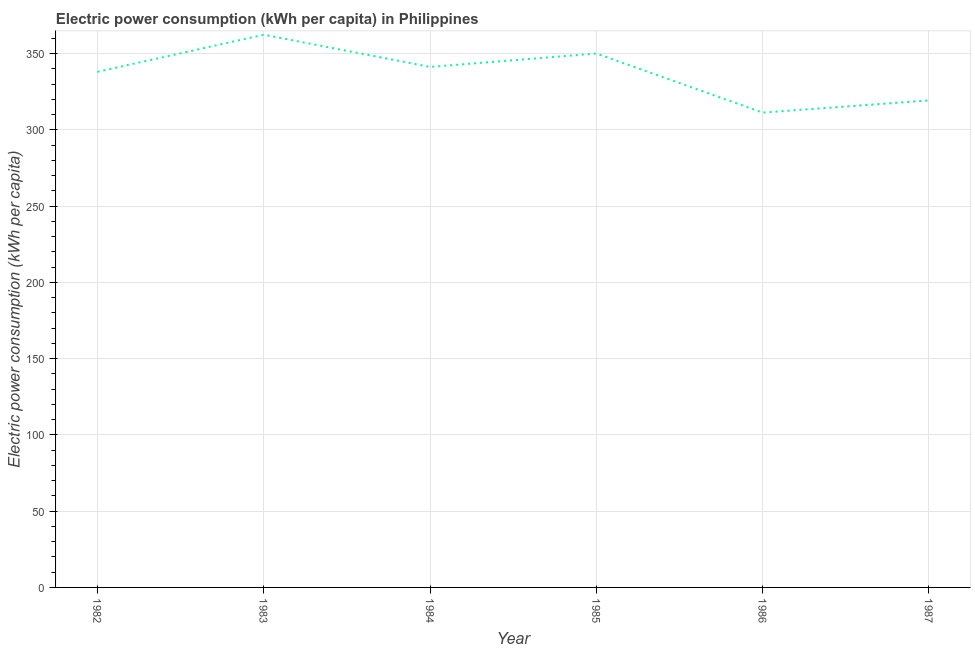What is the electric power consumption in 1984?
Provide a succinct answer. 341.32. Across all years, what is the maximum electric power consumption?
Offer a very short reply. 362.45. Across all years, what is the minimum electric power consumption?
Make the answer very short. 311.38. In which year was the electric power consumption maximum?
Provide a short and direct response. 1983. What is the sum of the electric power consumption?
Make the answer very short. 2022.78. What is the difference between the electric power consumption in 1982 and 1986?
Your answer should be very brief. 26.76. What is the average electric power consumption per year?
Offer a very short reply. 337.13. What is the median electric power consumption?
Make the answer very short. 339.73. In how many years, is the electric power consumption greater than 320 kWh per capita?
Ensure brevity in your answer.  4. What is the ratio of the electric power consumption in 1985 to that in 1987?
Offer a terse response. 1.1. Is the difference between the electric power consumption in 1985 and 1987 greater than the difference between any two years?
Your response must be concise. No. What is the difference between the highest and the second highest electric power consumption?
Make the answer very short. 12.33. Is the sum of the electric power consumption in 1983 and 1986 greater than the maximum electric power consumption across all years?
Make the answer very short. Yes. What is the difference between the highest and the lowest electric power consumption?
Keep it short and to the point. 51.08. In how many years, is the electric power consumption greater than the average electric power consumption taken over all years?
Give a very brief answer. 4. Does the electric power consumption monotonically increase over the years?
Your answer should be compact. No. How many lines are there?
Provide a succinct answer. 1. What is the difference between two consecutive major ticks on the Y-axis?
Make the answer very short. 50. Does the graph contain any zero values?
Offer a terse response. No. Does the graph contain grids?
Your response must be concise. Yes. What is the title of the graph?
Provide a short and direct response. Electric power consumption (kWh per capita) in Philippines. What is the label or title of the Y-axis?
Your response must be concise. Electric power consumption (kWh per capita). What is the Electric power consumption (kWh per capita) of 1982?
Ensure brevity in your answer.  338.14. What is the Electric power consumption (kWh per capita) of 1983?
Your response must be concise. 362.45. What is the Electric power consumption (kWh per capita) in 1984?
Give a very brief answer. 341.32. What is the Electric power consumption (kWh per capita) in 1985?
Ensure brevity in your answer.  350.12. What is the Electric power consumption (kWh per capita) of 1986?
Provide a short and direct response. 311.38. What is the Electric power consumption (kWh per capita) of 1987?
Ensure brevity in your answer.  319.37. What is the difference between the Electric power consumption (kWh per capita) in 1982 and 1983?
Your answer should be compact. -24.32. What is the difference between the Electric power consumption (kWh per capita) in 1982 and 1984?
Keep it short and to the point. -3.18. What is the difference between the Electric power consumption (kWh per capita) in 1982 and 1985?
Make the answer very short. -11.99. What is the difference between the Electric power consumption (kWh per capita) in 1982 and 1986?
Provide a succinct answer. 26.76. What is the difference between the Electric power consumption (kWh per capita) in 1982 and 1987?
Provide a short and direct response. 18.77. What is the difference between the Electric power consumption (kWh per capita) in 1983 and 1984?
Provide a succinct answer. 21.13. What is the difference between the Electric power consumption (kWh per capita) in 1983 and 1985?
Provide a succinct answer. 12.33. What is the difference between the Electric power consumption (kWh per capita) in 1983 and 1986?
Give a very brief answer. 51.08. What is the difference between the Electric power consumption (kWh per capita) in 1983 and 1987?
Offer a terse response. 43.08. What is the difference between the Electric power consumption (kWh per capita) in 1984 and 1985?
Your response must be concise. -8.8. What is the difference between the Electric power consumption (kWh per capita) in 1984 and 1986?
Make the answer very short. 29.95. What is the difference between the Electric power consumption (kWh per capita) in 1984 and 1987?
Give a very brief answer. 21.95. What is the difference between the Electric power consumption (kWh per capita) in 1985 and 1986?
Give a very brief answer. 38.75. What is the difference between the Electric power consumption (kWh per capita) in 1985 and 1987?
Offer a very short reply. 30.75. What is the difference between the Electric power consumption (kWh per capita) in 1986 and 1987?
Your answer should be compact. -7.99. What is the ratio of the Electric power consumption (kWh per capita) in 1982 to that in 1983?
Your response must be concise. 0.93. What is the ratio of the Electric power consumption (kWh per capita) in 1982 to that in 1984?
Ensure brevity in your answer.  0.99. What is the ratio of the Electric power consumption (kWh per capita) in 1982 to that in 1986?
Make the answer very short. 1.09. What is the ratio of the Electric power consumption (kWh per capita) in 1982 to that in 1987?
Give a very brief answer. 1.06. What is the ratio of the Electric power consumption (kWh per capita) in 1983 to that in 1984?
Offer a very short reply. 1.06. What is the ratio of the Electric power consumption (kWh per capita) in 1983 to that in 1985?
Provide a succinct answer. 1.03. What is the ratio of the Electric power consumption (kWh per capita) in 1983 to that in 1986?
Keep it short and to the point. 1.16. What is the ratio of the Electric power consumption (kWh per capita) in 1983 to that in 1987?
Ensure brevity in your answer.  1.14. What is the ratio of the Electric power consumption (kWh per capita) in 1984 to that in 1986?
Provide a succinct answer. 1.1. What is the ratio of the Electric power consumption (kWh per capita) in 1984 to that in 1987?
Give a very brief answer. 1.07. What is the ratio of the Electric power consumption (kWh per capita) in 1985 to that in 1986?
Your answer should be very brief. 1.12. What is the ratio of the Electric power consumption (kWh per capita) in 1985 to that in 1987?
Provide a succinct answer. 1.1. 